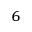Convert formula to latex. <formula><loc_0><loc_0><loc_500><loc_500>^ { 6 }</formula> 